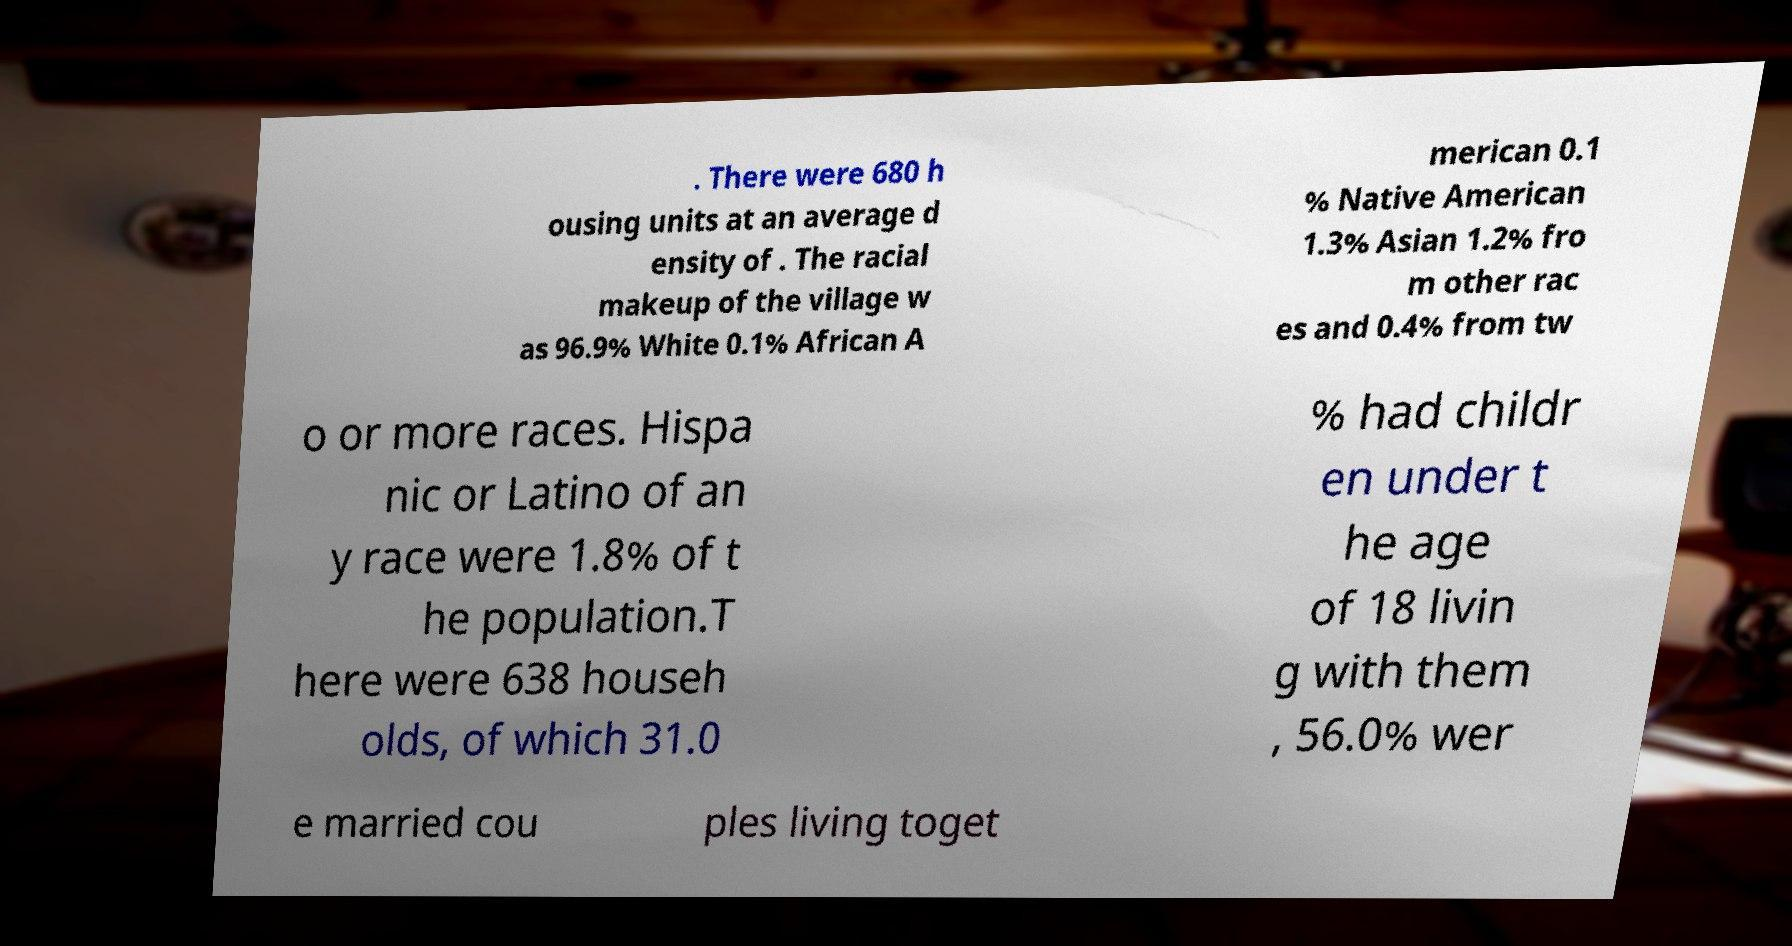Please read and relay the text visible in this image. What does it say? . There were 680 h ousing units at an average d ensity of . The racial makeup of the village w as 96.9% White 0.1% African A merican 0.1 % Native American 1.3% Asian 1.2% fro m other rac es and 0.4% from tw o or more races. Hispa nic or Latino of an y race were 1.8% of t he population.T here were 638 househ olds, of which 31.0 % had childr en under t he age of 18 livin g with them , 56.0% wer e married cou ples living toget 